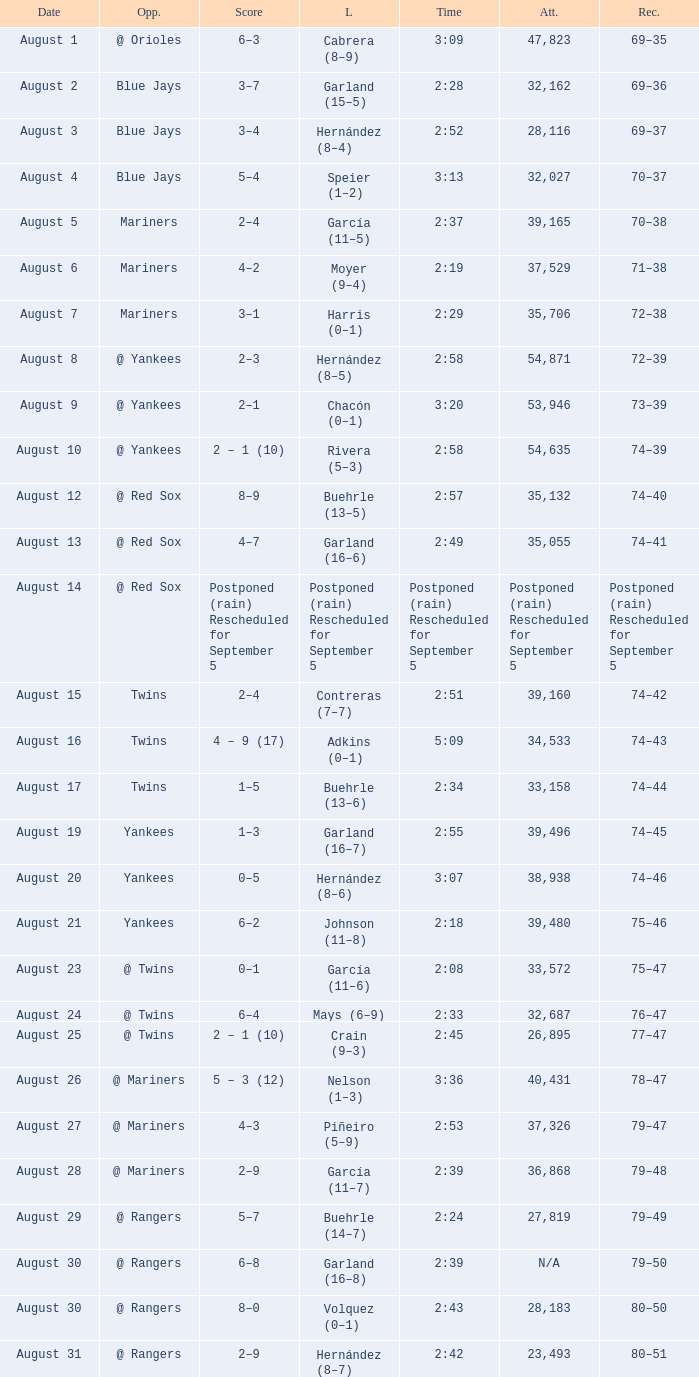Who was defeated with a timing of 2:42? Hernández (8–7). 